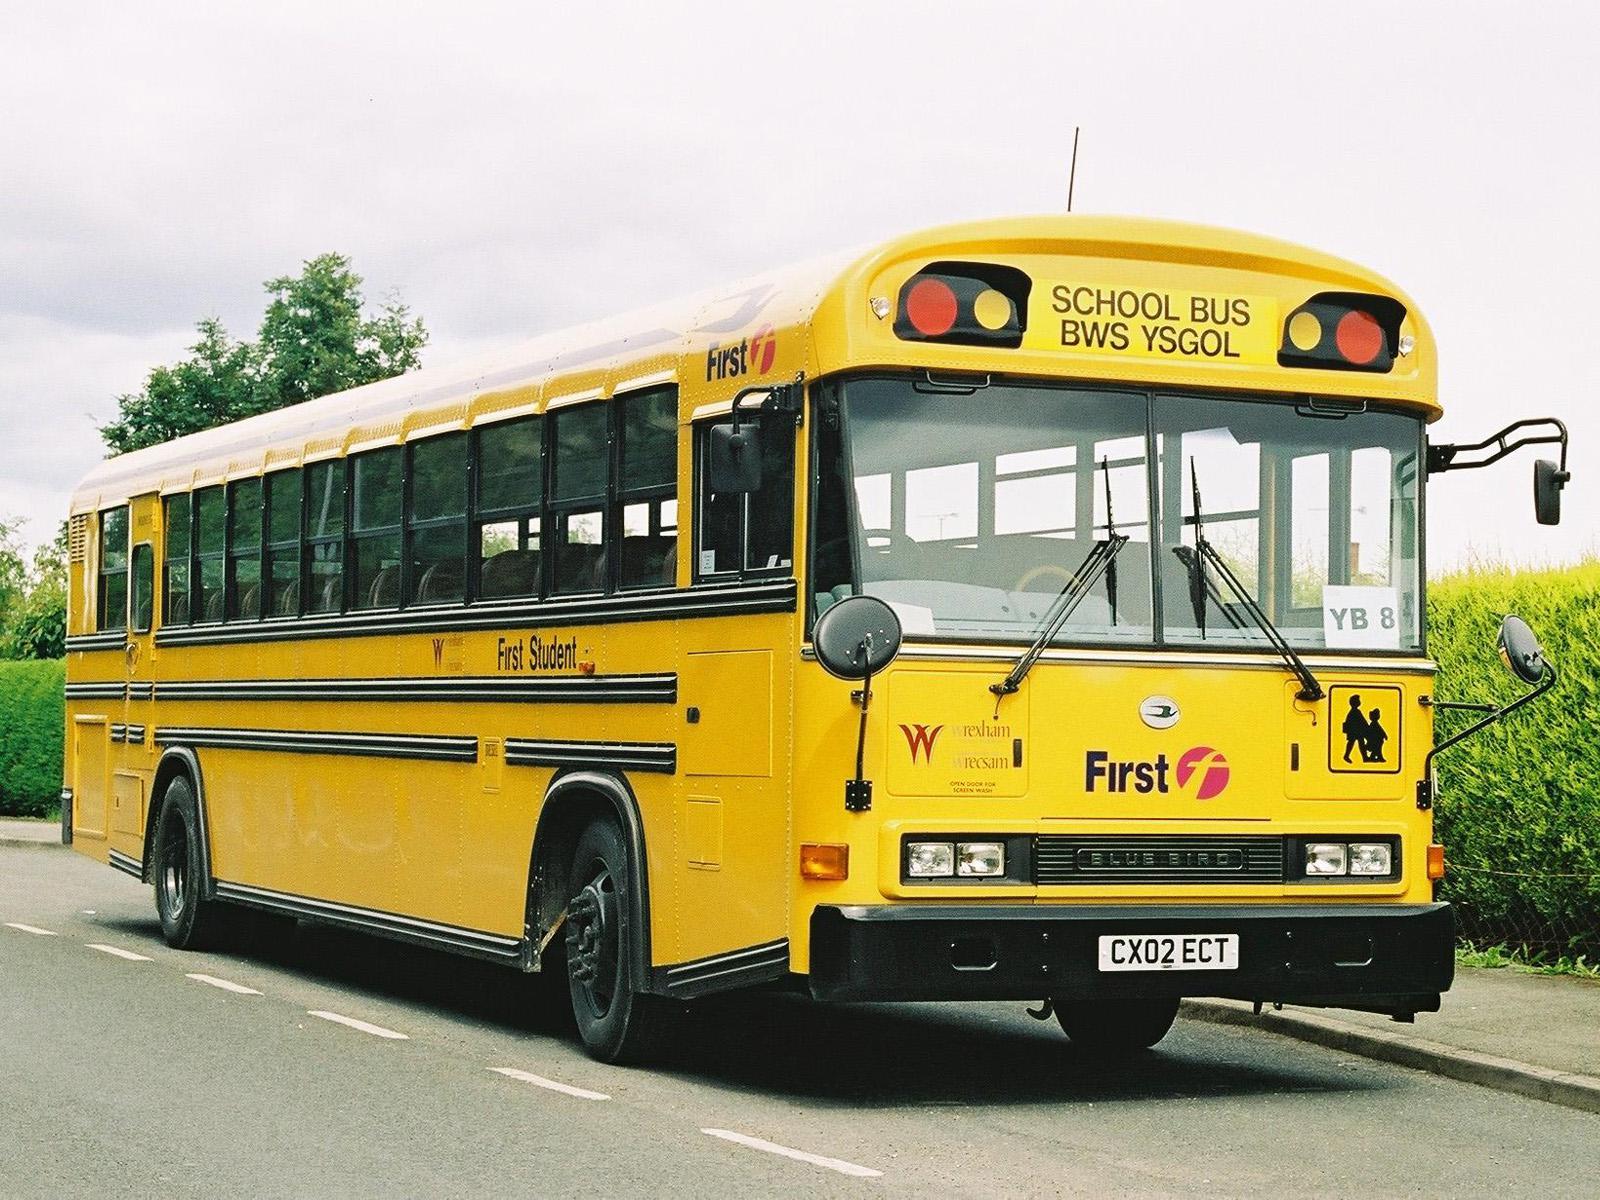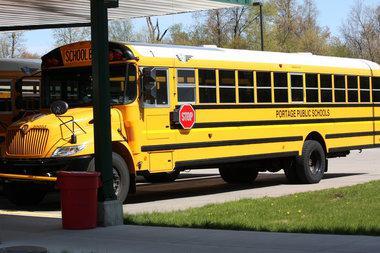The first image is the image on the left, the second image is the image on the right. For the images displayed, is the sentence "There is a school bus on a street with yellow lines and the stopsign on the bus is visible" factually correct? Answer yes or no. No. The first image is the image on the left, the second image is the image on the right. Assess this claim about the two images: "the left and right image contains the same number of buses.". Correct or not? Answer yes or no. Yes. 